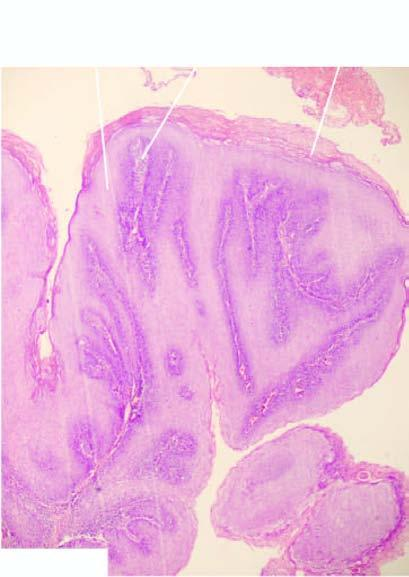what is there in the figure?
Answer the question using a single word or phrase. Papillomatosis 